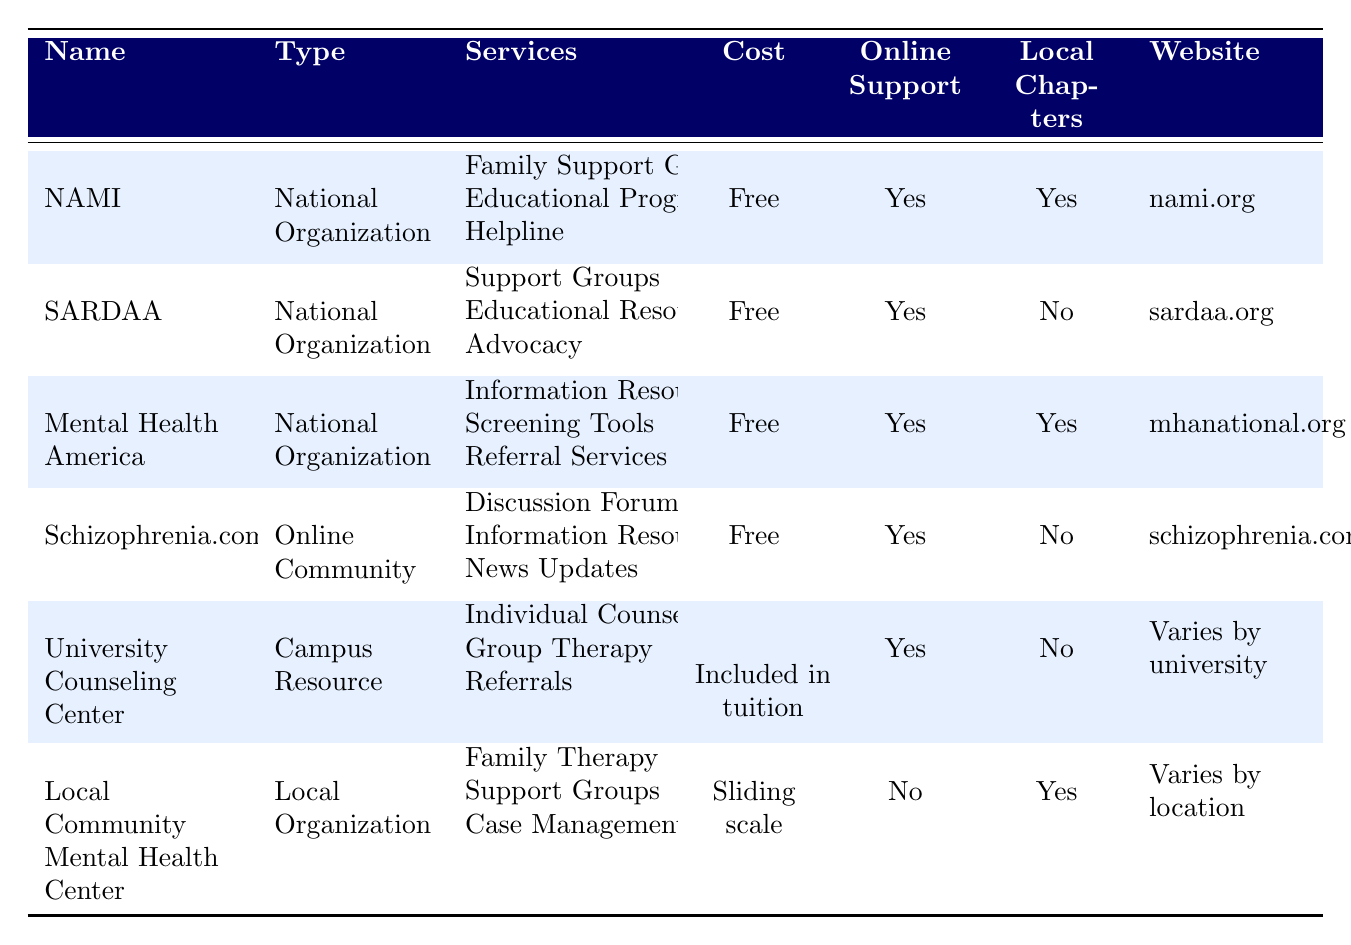What services does the National Alliance on Mental Illness (NAMI) offer? According to the table, NAMI offers three services: Family Support Groups, Educational Programs, and a Helpline. These are listed in the "Services" column for NAMI.
Answer: Family Support Groups, Educational Programs, Helpline Is the support provided by Schizophrenia and Related Disorders Alliance of America (SARDAA) free? The "Cost" column for SARDAA indicates that the services they offer are free.
Answer: Yes How many organizations provide online support? In the "Online Support" column, five out of the six organizations listed indicate that they provide online support (only the Local Community Mental Health Center does not). Therefore, we count the "Yes" responses in that column.
Answer: 5 Does the University Counseling Center have local chapters? Looking at the "Local Chapters" column for the University Counseling Center, it shows "No," indicating they do not have local chapters.
Answer: No Which organization has individual counseling as a service and what is its cost? The University Counseling Center provides Individual Counseling as one of its services, and the cost is included in tuition. These details can be found together in the respective columns of the table.
Answer: Included in tuition What is the cost of services at the Local Community Mental Health Center? The "Cost" column for the Local Community Mental Health Center indicates a sliding scale for their services.
Answer: Sliding scale Is there any online community that offers information resources but not local chapters? The table shows that Schizophrenia.com offers Information Resources but does not have local chapters, as indicated under the "Local Chapters" column.
Answer: Yes Which organization offers support groups and local chapters? Both NAMI and Mental Health America offer support groups and also have local chapters, as indicated in their respective rows in the "Services" and "Local Chapters" columns.
Answer: NAMI, Mental Health America 